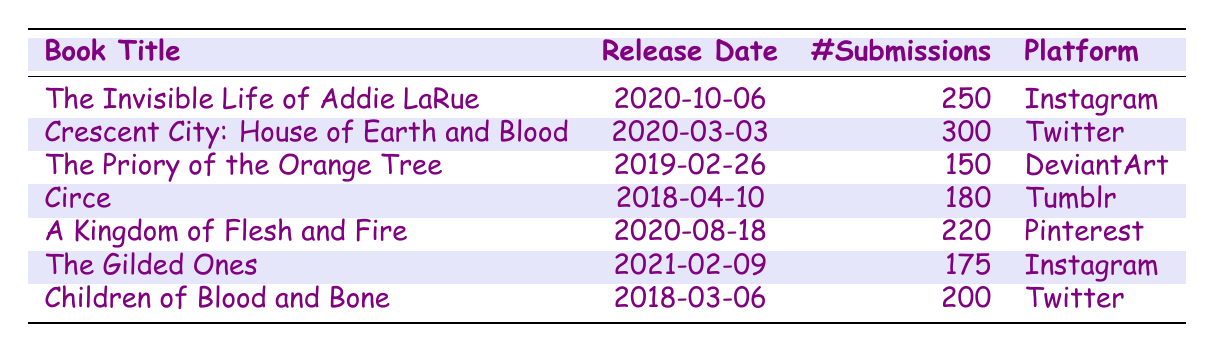What is the total number of fan art submissions for all the books listed? To find the total number of submissions, we sum the submissions from each book: 250 + 300 + 150 + 180 + 220 + 175 + 200 = 1475.
Answer: 1475 Which book had the highest number of fan art submissions? By inspecting the number of submissions for each book, "Crescent City: House of Earth and Blood" has the highest submissions with 300.
Answer: Crescent City: House of Earth and Blood Is the number of submissions for "The Gilded Ones" greater than 150? The number of submissions for "The Gilded Ones" is 175, which is greater than 150.
Answer: Yes What is the average number of submissions for books released after 2019? The books released after 2019 with their submissions are "The Invisible Life of Addie LaRue" (250), "Crescent City: House of Earth and Blood" (300), "A Kingdom of Flesh and Fire" (220), and "The Gilded Ones" (175). The sum is 250 + 300 + 220 + 175 = 945. There are 4 books, so the average is 945/4 = 236.25.
Answer: 236.25 On which platform was "Circe" submitted? The platform listed for "Circe" is Tumblr.
Answer: Tumblr How many more submissions did "Children of Blood and Bone" receive compared to "The Priory of the Orange Tree"? "Children of Blood and Bone" received 200 submissions, and "The Priory of the Orange Tree" received 150 submissions. The difference is 200 - 150 = 50.
Answer: 50 Is it true that there are more submissions for fan art on Instagram than on DeviantArt? Yes, "The Invisible Life of Addie LaRue" and "The Gilded Ones" on Instagram total 250 + 175 = 425 submissions, while "The Priory of the Orange Tree" on DeviantArt has only 150 submissions.
Answer: Yes What is the relationship between the release date and the number of submissions for "A Kingdom of Flesh and Fire"? This book was released on 2020-08-18 and received 220 submissions, which is notable as it's one of the higher counts among books released in 2020.
Answer: 220 submissions 